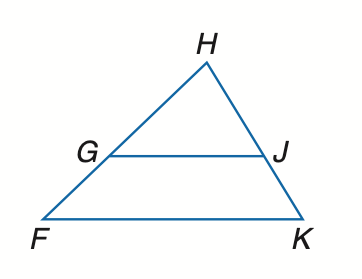Question: Find x so that G J \parallel F K. H J = x - 5, J K = 15, F G = 18, H G = x - 4.
Choices:
A. 10
B. 12
C. 15
D. 18
Answer with the letter. Answer: A 